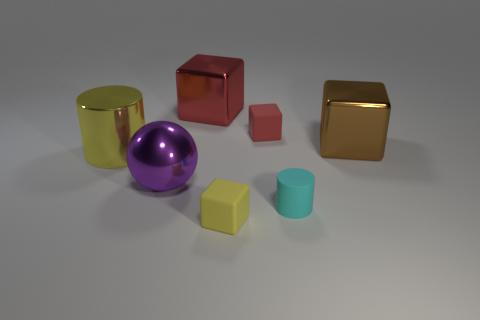Subtract all yellow blocks. How many blocks are left? 3 Subtract all spheres. How many objects are left? 6 Subtract all brown blocks. How many blocks are left? 3 Add 1 large brown metal objects. How many objects exist? 8 Subtract 1 spheres. How many spheres are left? 0 Subtract all big blue balls. Subtract all yellow shiny cylinders. How many objects are left? 6 Add 7 rubber cylinders. How many rubber cylinders are left? 8 Add 6 small red shiny things. How many small red shiny things exist? 6 Subtract 0 cyan balls. How many objects are left? 7 Subtract all green cylinders. Subtract all purple blocks. How many cylinders are left? 2 